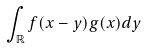Convert formula to latex. <formula><loc_0><loc_0><loc_500><loc_500>\int _ { \mathbb { R } } f ( x - y ) g ( x ) d y</formula> 